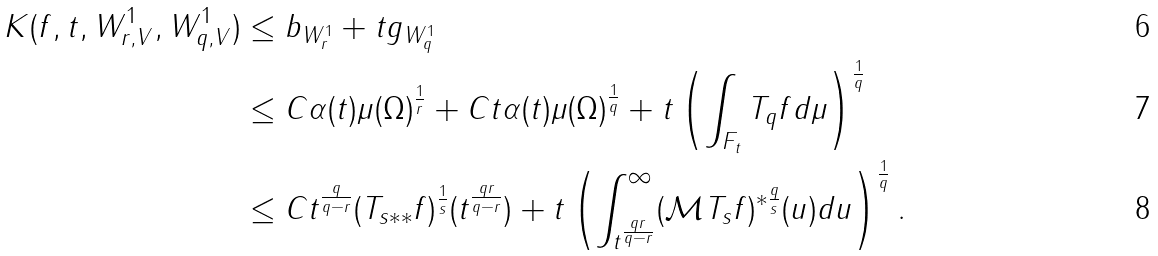Convert formula to latex. <formula><loc_0><loc_0><loc_500><loc_500>K ( f , t , W _ { r , V } ^ { 1 } , W _ { q , V } ^ { 1 } ) & \leq \| b \| _ { W _ { r } ^ { 1 } } + t \| g \| _ { W _ { q } ^ { 1 } } \\ & \leq C \alpha ( t ) \mu ( \Omega ) ^ { \frac { 1 } { r } } + C t \alpha ( t ) \mu ( \Omega ) ^ { \frac { 1 } { q } } + t \left ( \int _ { F _ { t } } T _ { q } f d \mu \right ) ^ { \frac { 1 } { q } } \\ & \leq C t ^ { \frac { q } { q - r } } ( T _ { s * * } f ) ^ { \frac { 1 } { s } } ( t ^ { \frac { q r } { q - r } } ) + t \left ( \int _ { t ^ { \frac { q r } { q - r } } } ^ { \infty } ( \mathcal { M } T _ { s } f ) ^ { * \frac { q } { s } } ( u ) d u \right ) ^ { \frac { 1 } { q } } .</formula> 